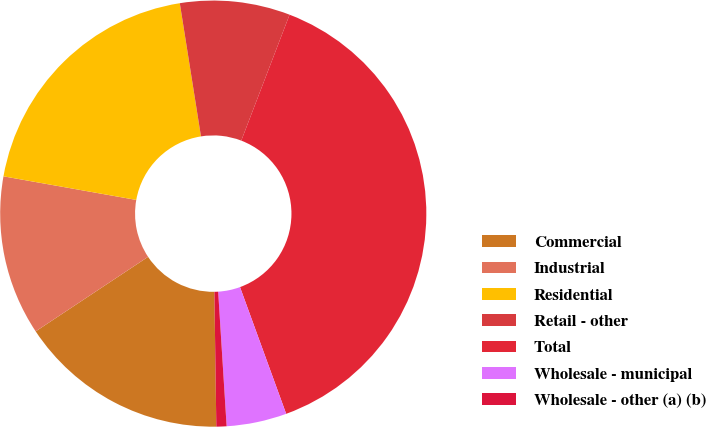Convert chart to OTSL. <chart><loc_0><loc_0><loc_500><loc_500><pie_chart><fcel>Commercial<fcel>Industrial<fcel>Residential<fcel>Retail - other<fcel>Total<fcel>Wholesale - municipal<fcel>Wholesale - other (a) (b)<nl><fcel>15.91%<fcel>12.12%<fcel>19.69%<fcel>8.34%<fcel>38.61%<fcel>4.56%<fcel>0.77%<nl></chart> 